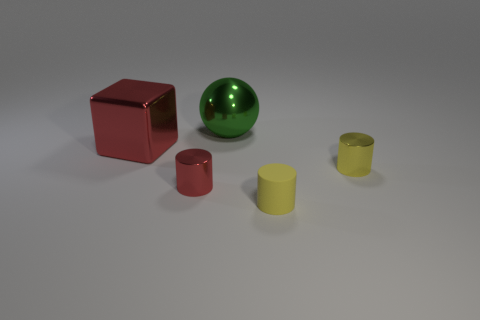There is a object behind the red object that is behind the tiny thing that is to the left of the large green shiny sphere; what size is it?
Offer a very short reply. Large. What number of other things are the same color as the matte cylinder?
Keep it short and to the point. 1. Is the color of the small metal cylinder on the right side of the small red cylinder the same as the block?
Your answer should be compact. No. What number of things are either gray spheres or large red metal objects?
Offer a terse response. 1. There is a tiny thing that is left of the matte thing; what color is it?
Provide a short and direct response. Red. Is the number of tiny red metallic things in front of the red cylinder less than the number of tiny shiny cylinders?
Give a very brief answer. Yes. The other cylinder that is the same color as the tiny matte cylinder is what size?
Offer a terse response. Small. Is there any other thing that is the same size as the metal cube?
Keep it short and to the point. Yes. Are the tiny red cylinder and the large green sphere made of the same material?
Offer a very short reply. Yes. What number of objects are either big objects that are to the right of the large red metal block or big green metallic spheres on the left side of the yellow metal thing?
Keep it short and to the point. 1. 